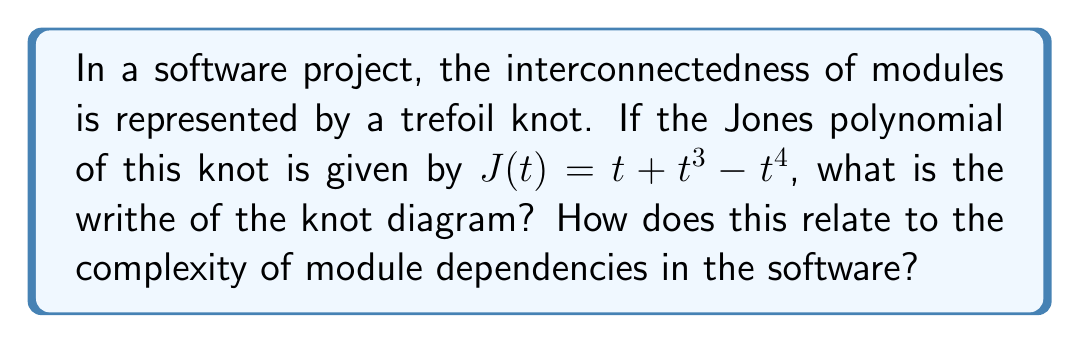Can you answer this question? To solve this problem, we'll follow these steps:

1. Recall the relation between the Jones polynomial and the writhe:
   The Jones polynomial $J(t)$ of a knot is related to its Kauffman bracket polynomial $\langle K \rangle$ by:
   
   $$J(t) = (-t^{3/4})^{-w(K)} \langle K \rangle$$
   
   where $w(K)$ is the writhe of the knot diagram.

2. For the trefoil knot, the Kauffman bracket polynomial is known to be:
   
   $$\langle K \rangle = -A^{-7} - A^{-3} - A^5$$

3. Substituting $A = t^{-1/4}$ into the Kauffman bracket polynomial:
   
   $$\langle K \rangle = -t^{7/4} - t^{3/4} - t^{-5/4}$$

4. Now, we can equate this to our given Jones polynomial:
   
   $$(-t^{3/4})^{-w(K)} (-t^{7/4} - t^{3/4} - t^{-5/4}) = t + t^3 - t^4$$

5. Simplifying the left side:
   
   $$t^{-3w(K)/4} (-t^{7/4} - t^{3/4} - t^{-5/4}) = t + t^3 - t^4$$

6. For this equation to hold, we must have:
   
   $$-3w(K)/4 + 7/4 = 1$$
   $$-3w(K)/4 + 3/4 = 3$$
   $$-3w(K)/4 - 5/4 = -4$$

7. Solving any of these equations (they're equivalent), we get:
   
   $$w(K) = -3$$

8. Interpretation for software complexity:
   The writhe of -3 indicates a high degree of crossing in the knot diagram. In terms of software, this suggests a complex interconnection between modules. A negative writhe implies that many of these connections may be creating "twists" or dependencies that complicate the overall structure. This high level of interconnectedness could lead to challenges in maintaining and updating the software, as changes in one module may have far-reaching effects on others.
Answer: $w(K) = -3$, indicating high module interdependency and potential maintenance challenges. 